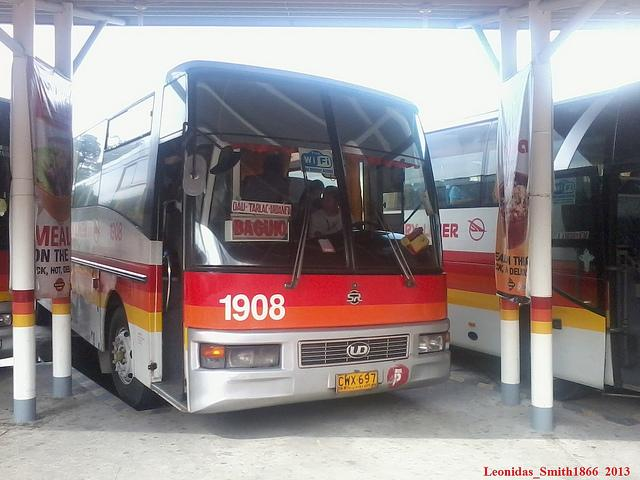What service is available when riding this bus?

Choices:
A) free lunch
B) wifi
C) hand towels
D) heated seats wifi 